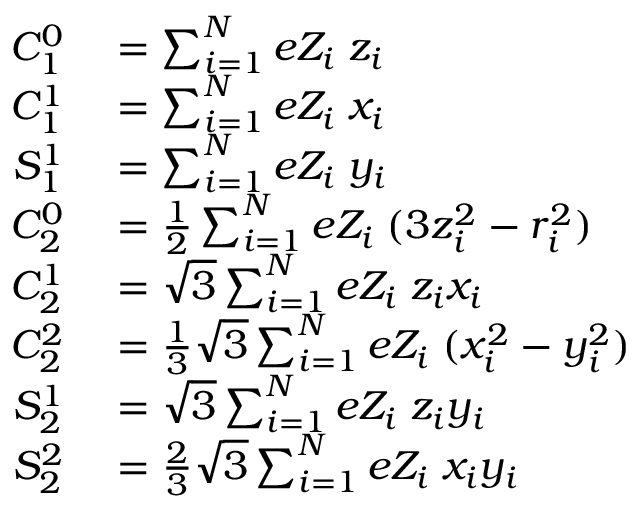Convert formula to latex. <formula><loc_0><loc_0><loc_500><loc_500>\begin{array} { r l } { C _ { 1 } ^ { 0 } } & = \sum _ { i = 1 } ^ { N } e Z _ { i } \, z _ { i } } \\ { C _ { 1 } ^ { 1 } } & = \sum _ { i = 1 } ^ { N } e Z _ { i } \, x _ { i } } \\ { S _ { 1 } ^ { 1 } } & = \sum _ { i = 1 } ^ { N } e Z _ { i } \, y _ { i } } \\ { C _ { 2 } ^ { 0 } } & = { \frac { 1 } { 2 } } \sum _ { i = 1 } ^ { N } e Z _ { i } \, ( 3 z _ { i } ^ { 2 } - r _ { i } ^ { 2 } ) } \\ { C _ { 2 } ^ { 1 } } & = { \sqrt { 3 } } \sum _ { i = 1 } ^ { N } e Z _ { i } \, z _ { i } x _ { i } } \\ { C _ { 2 } ^ { 2 } } & = { \frac { 1 } { 3 } } { \sqrt { 3 } } \sum _ { i = 1 } ^ { N } e Z _ { i } \, ( x _ { i } ^ { 2 } - y _ { i } ^ { 2 } ) } \\ { S _ { 2 } ^ { 1 } } & = { \sqrt { 3 } } \sum _ { i = 1 } ^ { N } e Z _ { i } \, z _ { i } y _ { i } } \\ { S _ { 2 } ^ { 2 } } & = { \frac { 2 } { 3 } } { \sqrt { 3 } } \sum _ { i = 1 } ^ { N } e Z _ { i } \, x _ { i } y _ { i } } \end{array}</formula> 